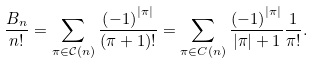Convert formula to latex. <formula><loc_0><loc_0><loc_500><loc_500>\frac { B _ { n } } { n ! } = \sum _ { \pi \in \mathcal { C } \left ( n \right ) } \frac { \left ( - 1 \right ) ^ { | \pi | } } { \left ( \pi + 1 \right ) ! } = \sum _ { \pi \in C \left ( n \right ) } \frac { \left ( - 1 \right ) ^ { | \pi | } } { | \pi | + 1 } \frac { 1 } { \pi ! } .</formula> 